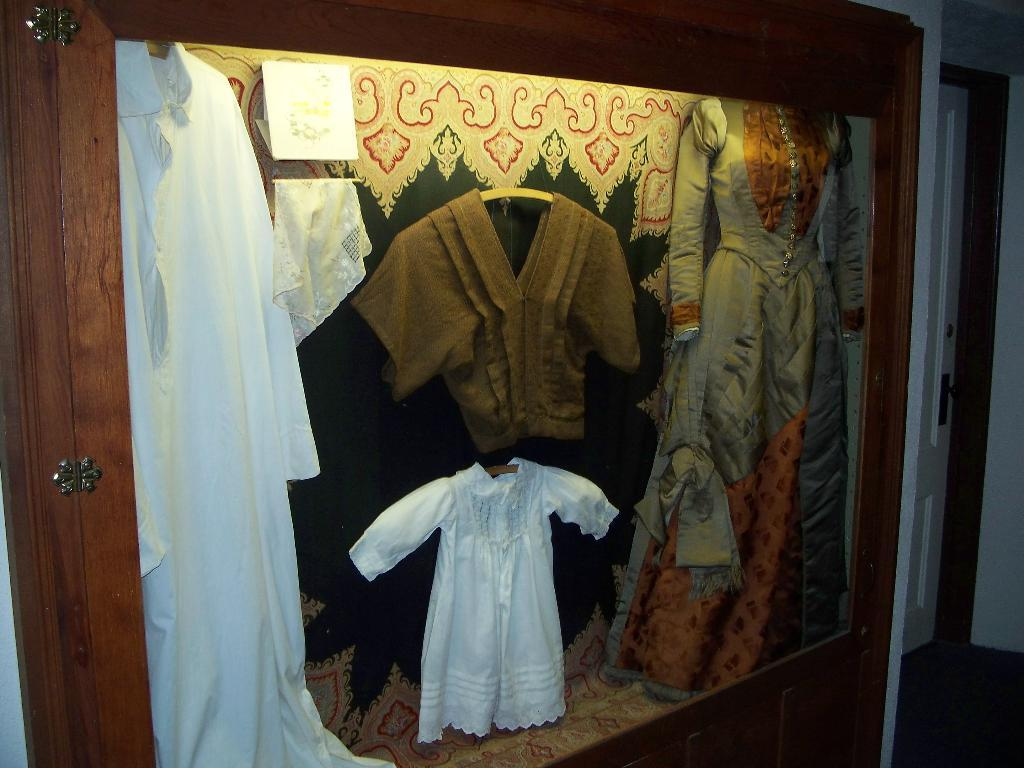What is the wooden object containing in the image? There are clothes in a wooden object in the image. What can be seen on the right side of the image? There is a door on the right side of the image. How many boys are combing their hair in the image? There are no boys present in the image, nor is there any combing activity. What causes a spark to appear in the image? There is no spark present in the image. 